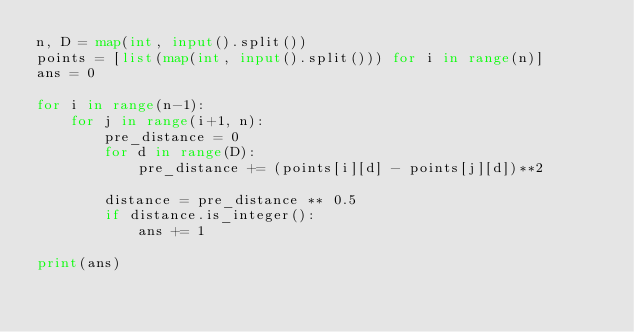Convert code to text. <code><loc_0><loc_0><loc_500><loc_500><_Python_>n, D = map(int, input().split())
points = [list(map(int, input().split())) for i in range(n)]
ans = 0

for i in range(n-1):
    for j in range(i+1, n):
        pre_distance = 0
        for d in range(D):
            pre_distance += (points[i][d] - points[j][d])**2

        distance = pre_distance ** 0.5
        if distance.is_integer():
            ans += 1

print(ans)
</code> 